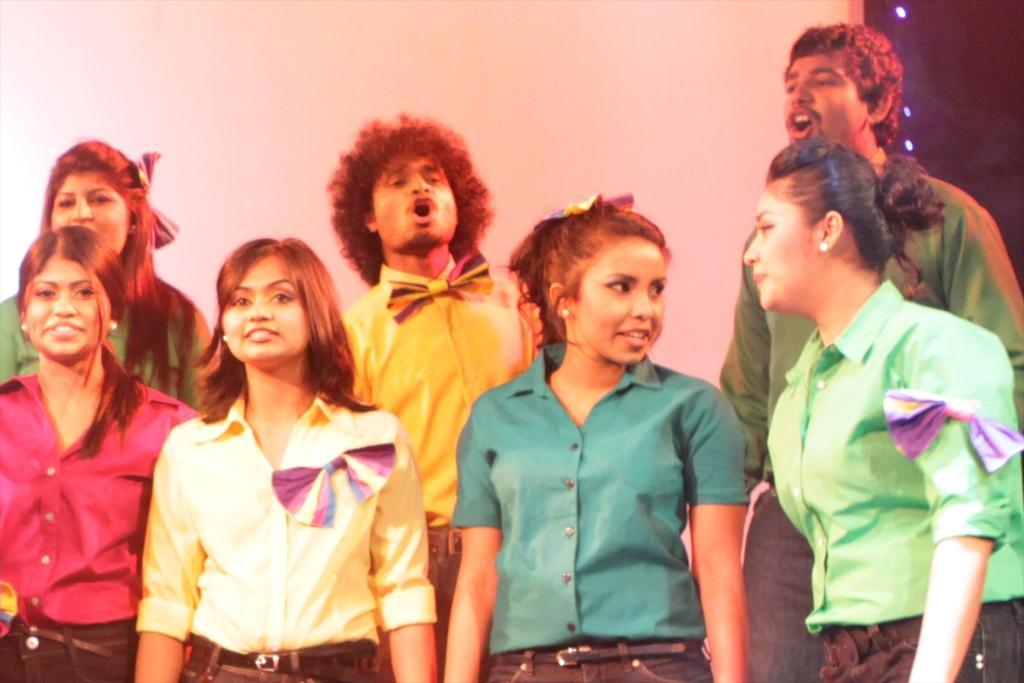In one or two sentences, can you explain what this image depicts? In this image I can see group of people are standing. These people are wearing shirts which are different in colors. 